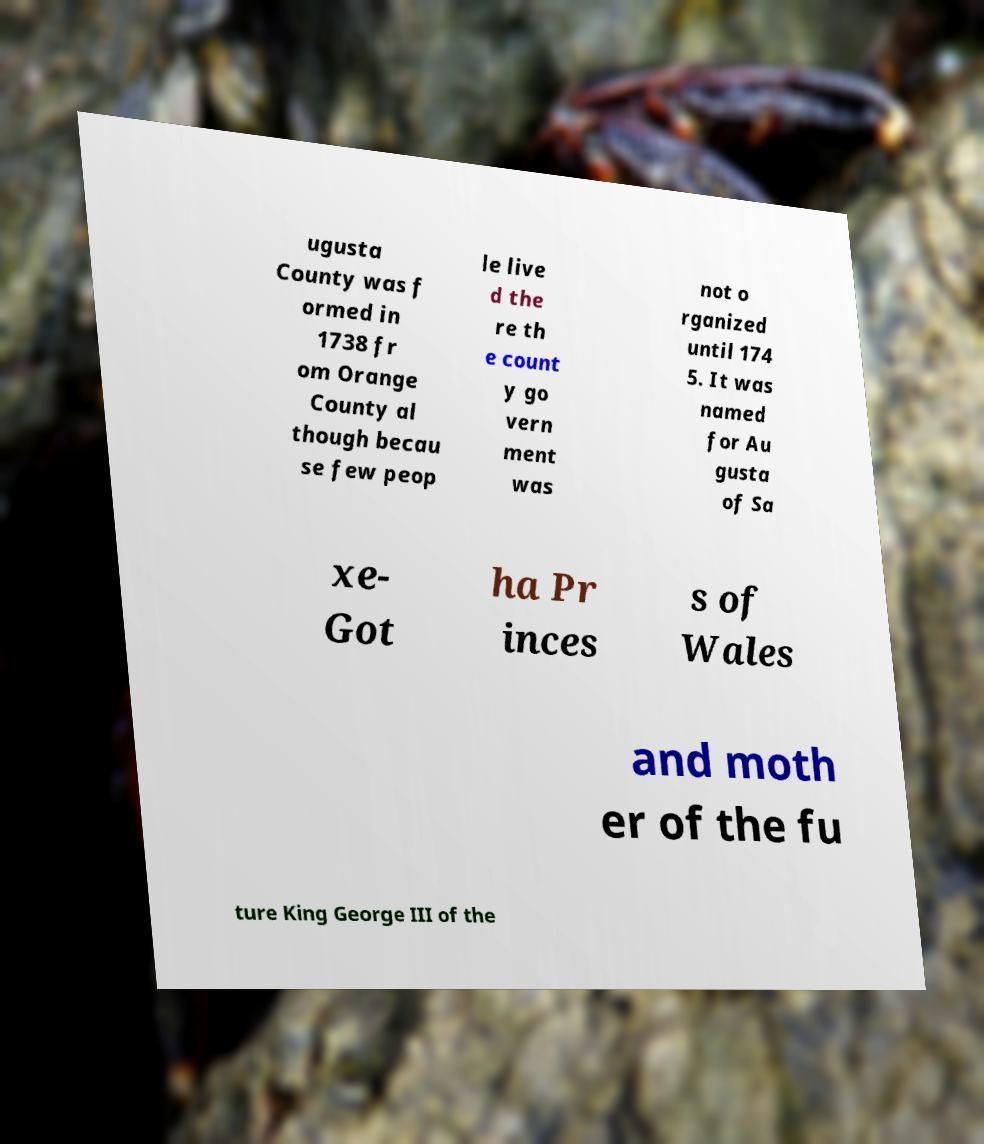There's text embedded in this image that I need extracted. Can you transcribe it verbatim? ugusta County was f ormed in 1738 fr om Orange County al though becau se few peop le live d the re th e count y go vern ment was not o rganized until 174 5. It was named for Au gusta of Sa xe- Got ha Pr inces s of Wales and moth er of the fu ture King George III of the 